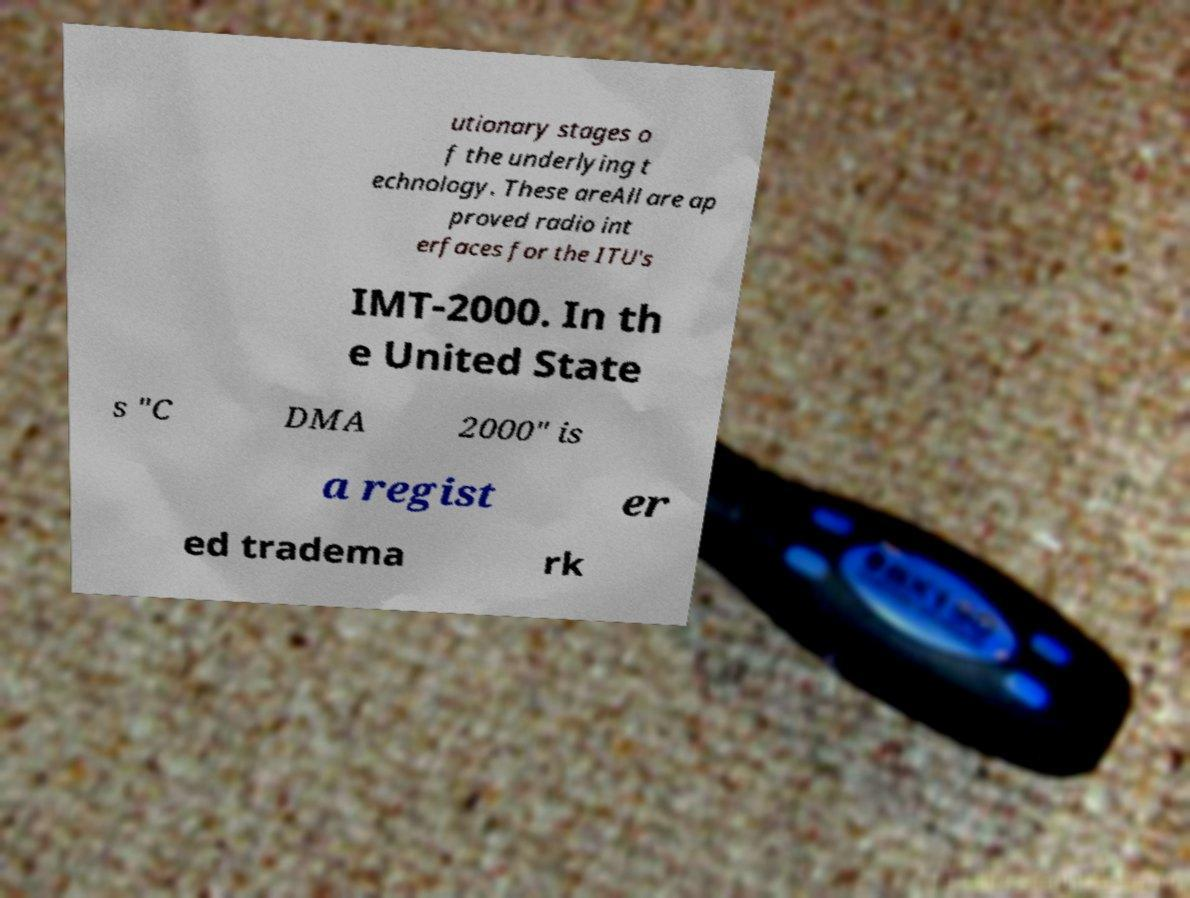There's text embedded in this image that I need extracted. Can you transcribe it verbatim? utionary stages o f the underlying t echnology. These areAll are ap proved radio int erfaces for the ITU's IMT-2000. In th e United State s "C DMA 2000" is a regist er ed tradema rk 